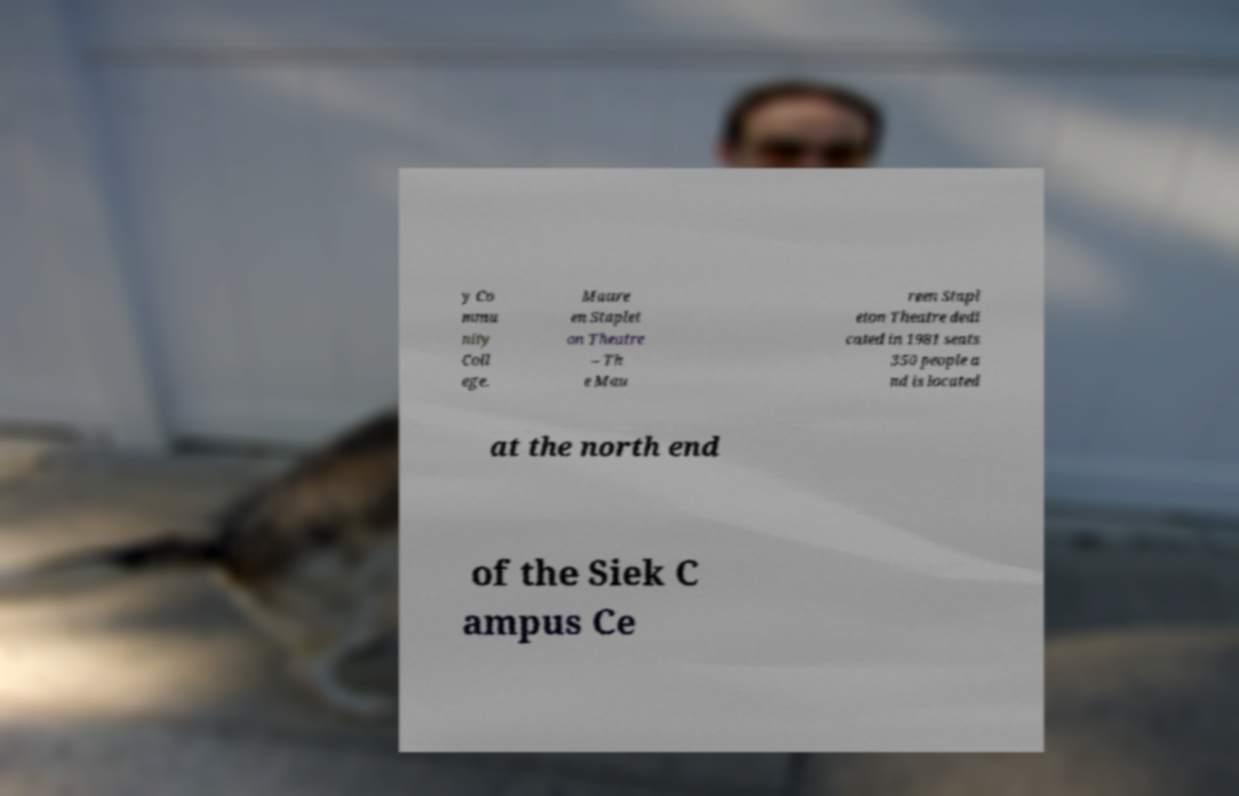There's text embedded in this image that I need extracted. Can you transcribe it verbatim? y Co mmu nity Coll ege. Maure en Staplet on Theatre – Th e Mau reen Stapl eton Theatre dedi cated in 1981 seats 350 people a nd is located at the north end of the Siek C ampus Ce 